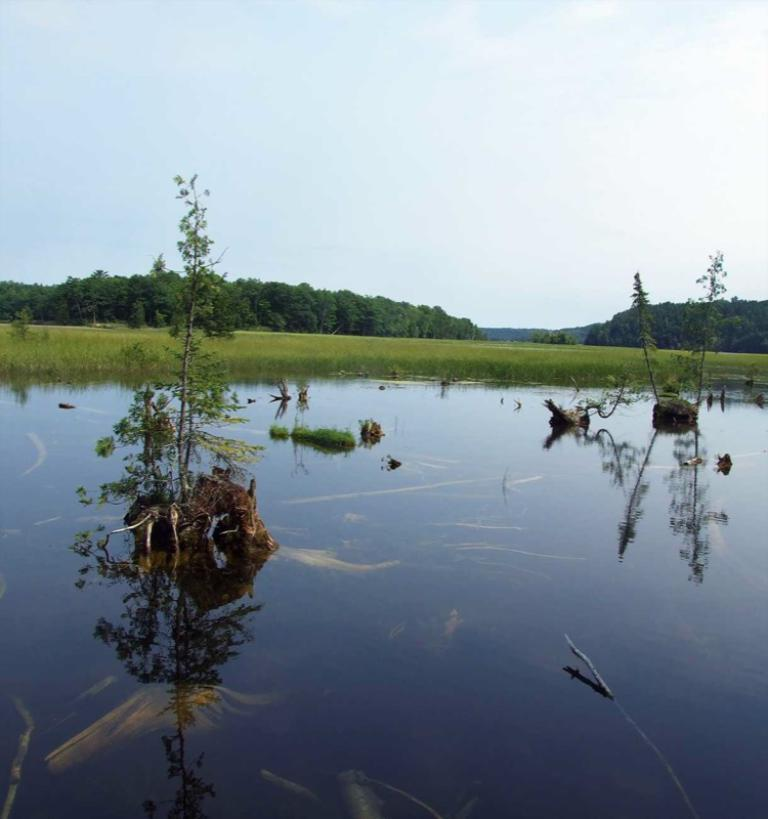What type of environment is depicted in the image? The image is an outside view. What can be seen in the water in the image? There are plants in the water. What type of vegetation is visible in the background? There is grass visible in the background. What else can be seen in the background of the image? There are many trees in the background. What is visible at the top of the image? The sky is visible at the top of the image. How many lizards can be seen in the image? There are no lizards present in the image. What type of zoo animals can be seen in the image? There is no zoo or any animals visible in the image; it is an outdoor scene with plants, grass, trees, and the sky. 